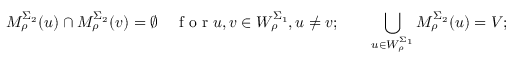<formula> <loc_0><loc_0><loc_500><loc_500>M _ { \rho } ^ { \Sigma _ { 2 } } ( u ) \cap M _ { \rho } ^ { \Sigma _ { 2 } } ( v ) = \emptyset \quad f o r u , v \in W _ { \rho } ^ { \Sigma _ { 1 } } , u \neq v ; \quad \bigcup _ { u \in W _ { \rho } ^ { \Sigma _ { 1 } } } M _ { \rho } ^ { \Sigma _ { 2 } } ( u ) = V ;</formula> 